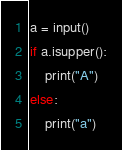Convert code to text. <code><loc_0><loc_0><loc_500><loc_500><_Python_>a = input()
if a.isupper():
    print("A")
else:
    print("a")
</code> 